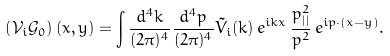Convert formula to latex. <formula><loc_0><loc_0><loc_500><loc_500>\left ( \mathcal { V } _ { i } \mathcal { G } _ { 0 } \right ) ( x , y ) = \int \frac { d ^ { 4 } k } { ( 2 \pi ) ^ { 4 } } \frac { d ^ { 4 } p } { ( 2 \pi ) ^ { 4 } } \tilde { V } _ { i } ( k ) \, e ^ { i k x } \, \frac { p _ { | | } ^ { 2 } } { p ^ { 2 } } \, e ^ { i p \cdot ( x - y ) } .</formula> 